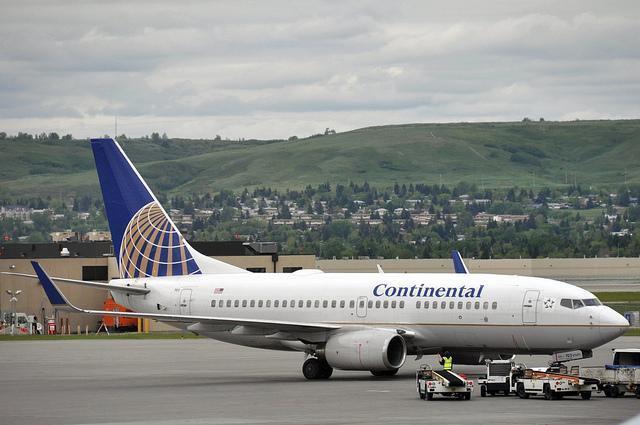Evaluate: Does the caption "The person is under the airplane." match the image?
Answer yes or no. Yes. 